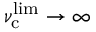Convert formula to latex. <formula><loc_0><loc_0><loc_500><loc_500>\nu _ { c } ^ { l i m } \rightarrow \infty</formula> 